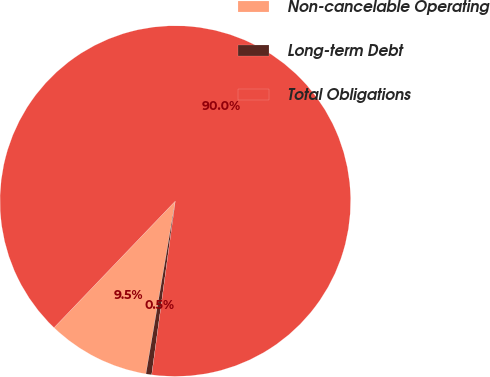<chart> <loc_0><loc_0><loc_500><loc_500><pie_chart><fcel>Non-cancelable Operating<fcel>Long-term Debt<fcel>Total Obligations<nl><fcel>9.48%<fcel>0.53%<fcel>89.99%<nl></chart> 